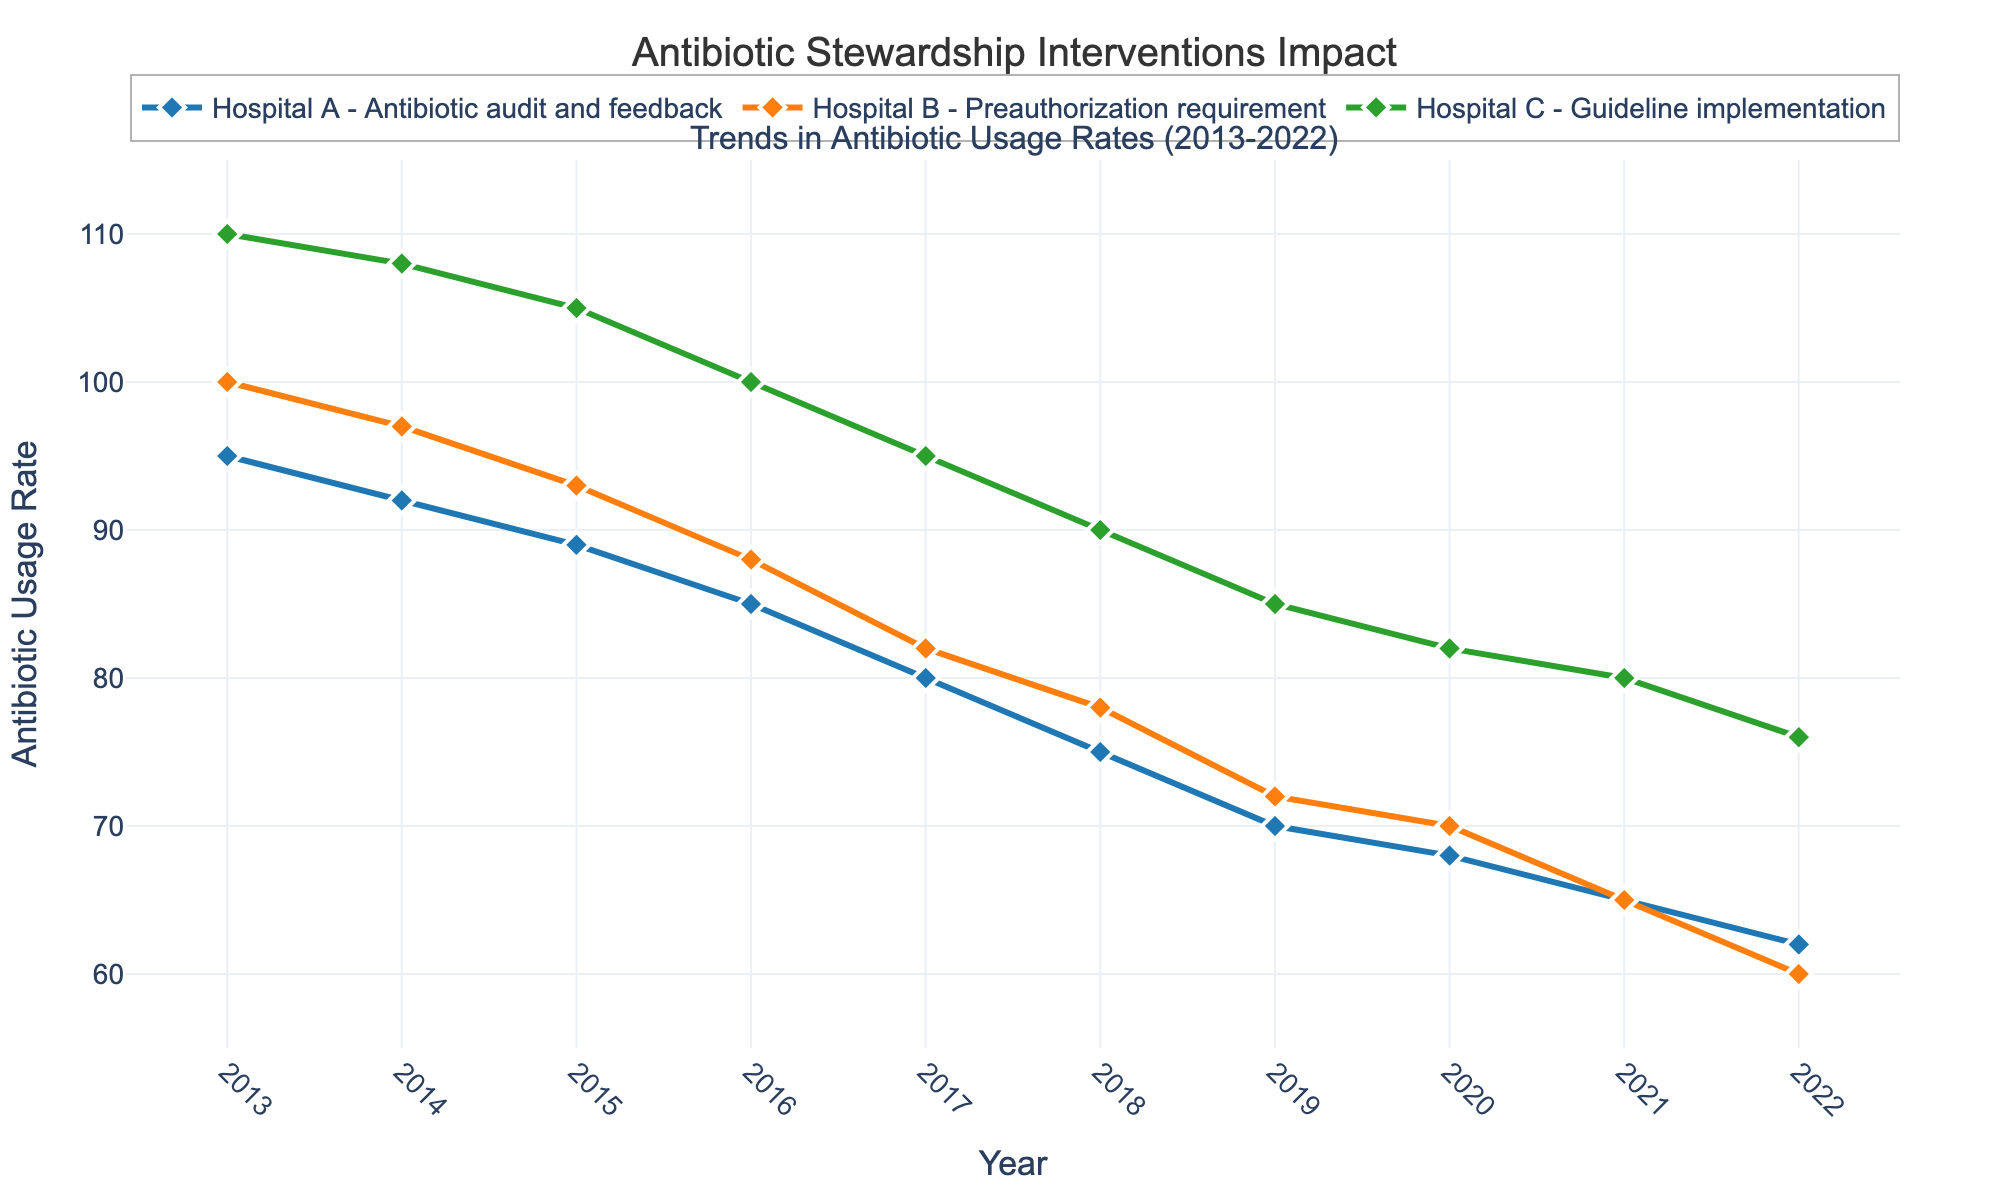How many hospitals are included in the plot? The plot shows data from three different hospitals described in the figure legend and represented by three lines.
Answer: Three Which intervention is associated with the largest initial antibiotic usage rate? By looking at the starting points of the lines in the plot, Hospital C has the highest starting rate of 110 in 2013, corresponding to the Guideline implementation intervention.
Answer: Guideline implementation How does the antibiotic usage rate for Hospital A change from 2013 to 2022? To determine this, observe the line for Hospital A, which starts at 95 in 2013 and decreases to 62 in 2022, showing a downward trend.
Answer: Decreases What is the overall trend for antibiotic usage rates in all hospitals from 2013 to 2022? Observing all three lines in the plot, we can see that they all show a decreasing trend in antibiotic usage rates over time.
Answer: Decreasing Which hospital shows the greatest reduction in antibiotic usage rate over the decade? By calculating the difference between initial and final rates, Hospital B has reduced from 100 to 60, making a 40-point reduction.
Answer: Hospital B In which year did Hospital A and Hospital B have the same antibiotic usage rate? The lines for Hospital A and Hospital B intersect in 2021 at the usage rate of 65.
Answer: 2021 How does the antibiotic usage rate of Hospital C compare to Hospital A in 2022? In the year 2022, Hospital C shows a rate of 76, while Hospital A shows 62, making Hospital C's rate higher than Hospital A's.
Answer: Higher What is the average antibiotic usage rate for Hospital A over the decade? Summing up the yearly values (95+92+89+85+80+75+70+68+65+62) and dividing by 10 gives the average rate. The sum is 781, so the average is 781/10 = 78.1.
Answer: 78.1 Which intervention appears to be most effective based on the rate reduction? Comparing the reductions: Hospital A (Antibiotic audit and feedback) drops 33 points, Hospital B (Preauthorization requirement) drops 40 points, and Hospital C (Guideline implementation) drops 34 points. The Preauthorization requirement in Hospital B shows the largest reduction.
Answer: Preauthorization requirement 